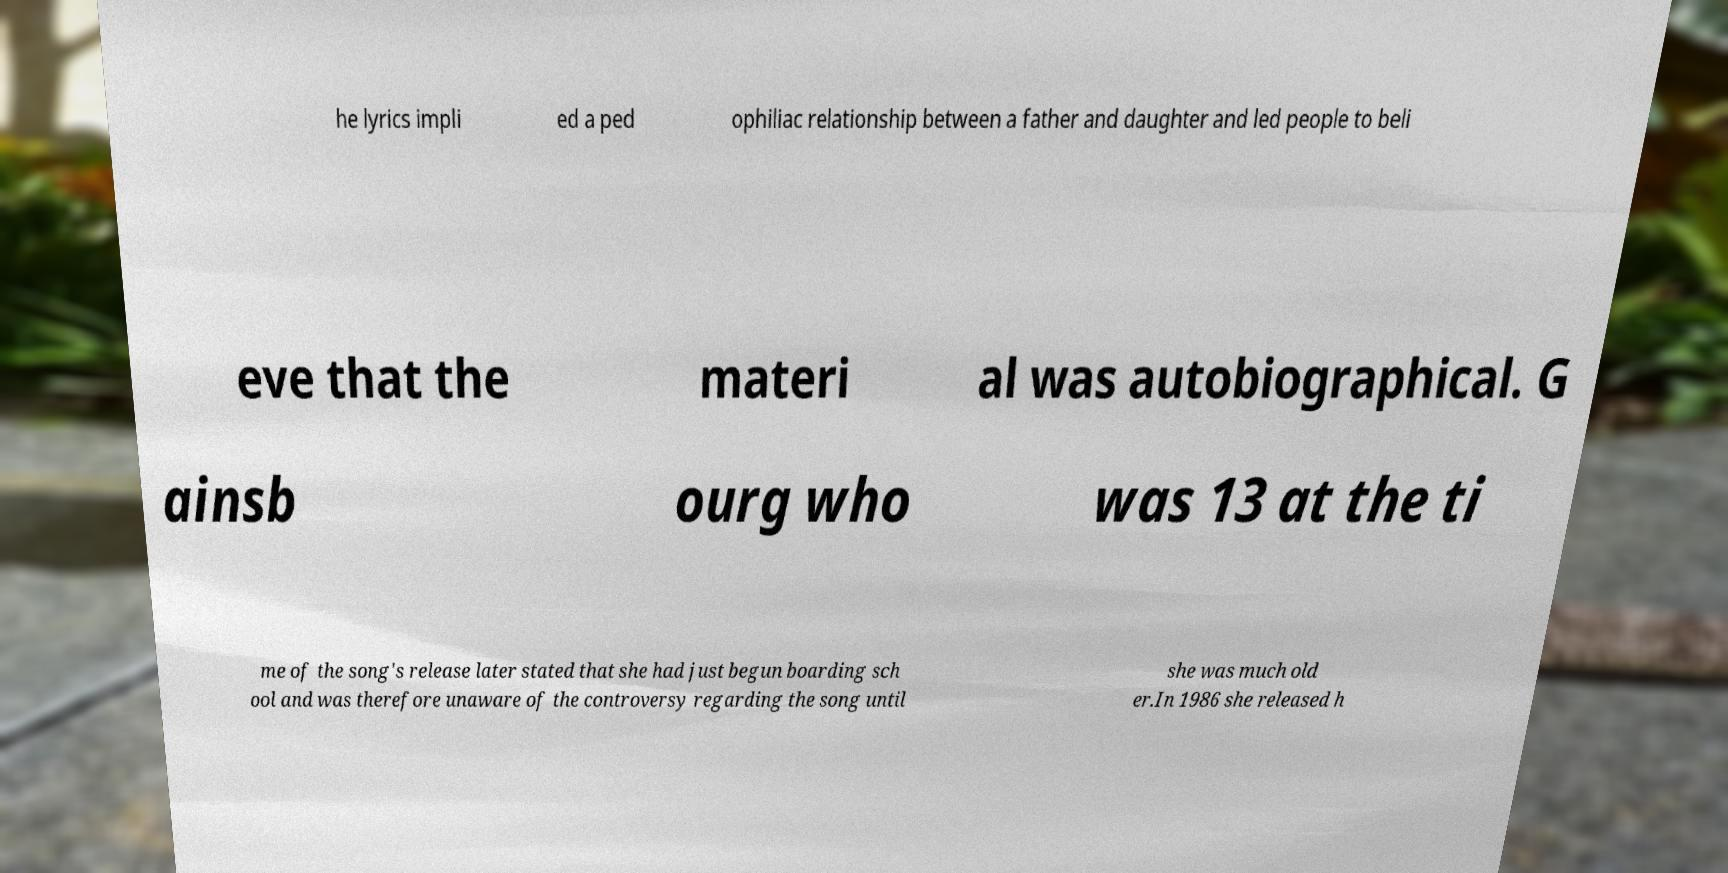I need the written content from this picture converted into text. Can you do that? he lyrics impli ed a ped ophiliac relationship between a father and daughter and led people to beli eve that the materi al was autobiographical. G ainsb ourg who was 13 at the ti me of the song's release later stated that she had just begun boarding sch ool and was therefore unaware of the controversy regarding the song until she was much old er.In 1986 she released h 